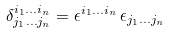Convert formula to latex. <formula><loc_0><loc_0><loc_500><loc_500>\delta _ { j _ { 1 } \dots j _ { n } } ^ { i _ { 1 } \dots i _ { n } } = \epsilon ^ { i _ { 1 } \dots i _ { n } } \, \epsilon _ { j _ { 1 } \dots j _ { n } }</formula> 